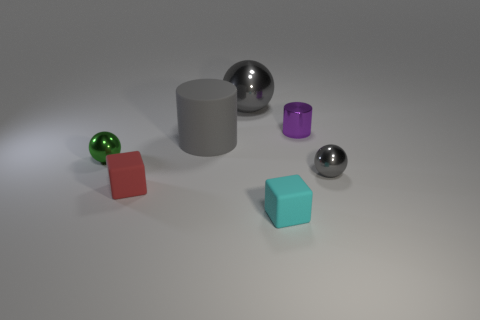The other metallic thing that is the same color as the big metal thing is what shape?
Your answer should be compact. Sphere. Is there anything else of the same color as the matte cylinder?
Offer a terse response. Yes. Are there fewer small metal spheres behind the small green metallic ball than tiny purple spheres?
Your answer should be compact. No. How many small objects are either blue blocks or cyan matte objects?
Your answer should be compact. 1. How big is the matte cylinder?
Keep it short and to the point. Large. What number of red cubes are in front of the small cyan rubber cube?
Keep it short and to the point. 0. There is another purple object that is the same shape as the large matte thing; what size is it?
Keep it short and to the point. Small. There is a rubber object that is to the left of the big metallic ball and right of the red rubber object; what size is it?
Offer a very short reply. Large. Do the matte cylinder and the large thing that is behind the large matte cylinder have the same color?
Offer a terse response. Yes. How many cyan things are metal cylinders or small metal spheres?
Provide a short and direct response. 0. 